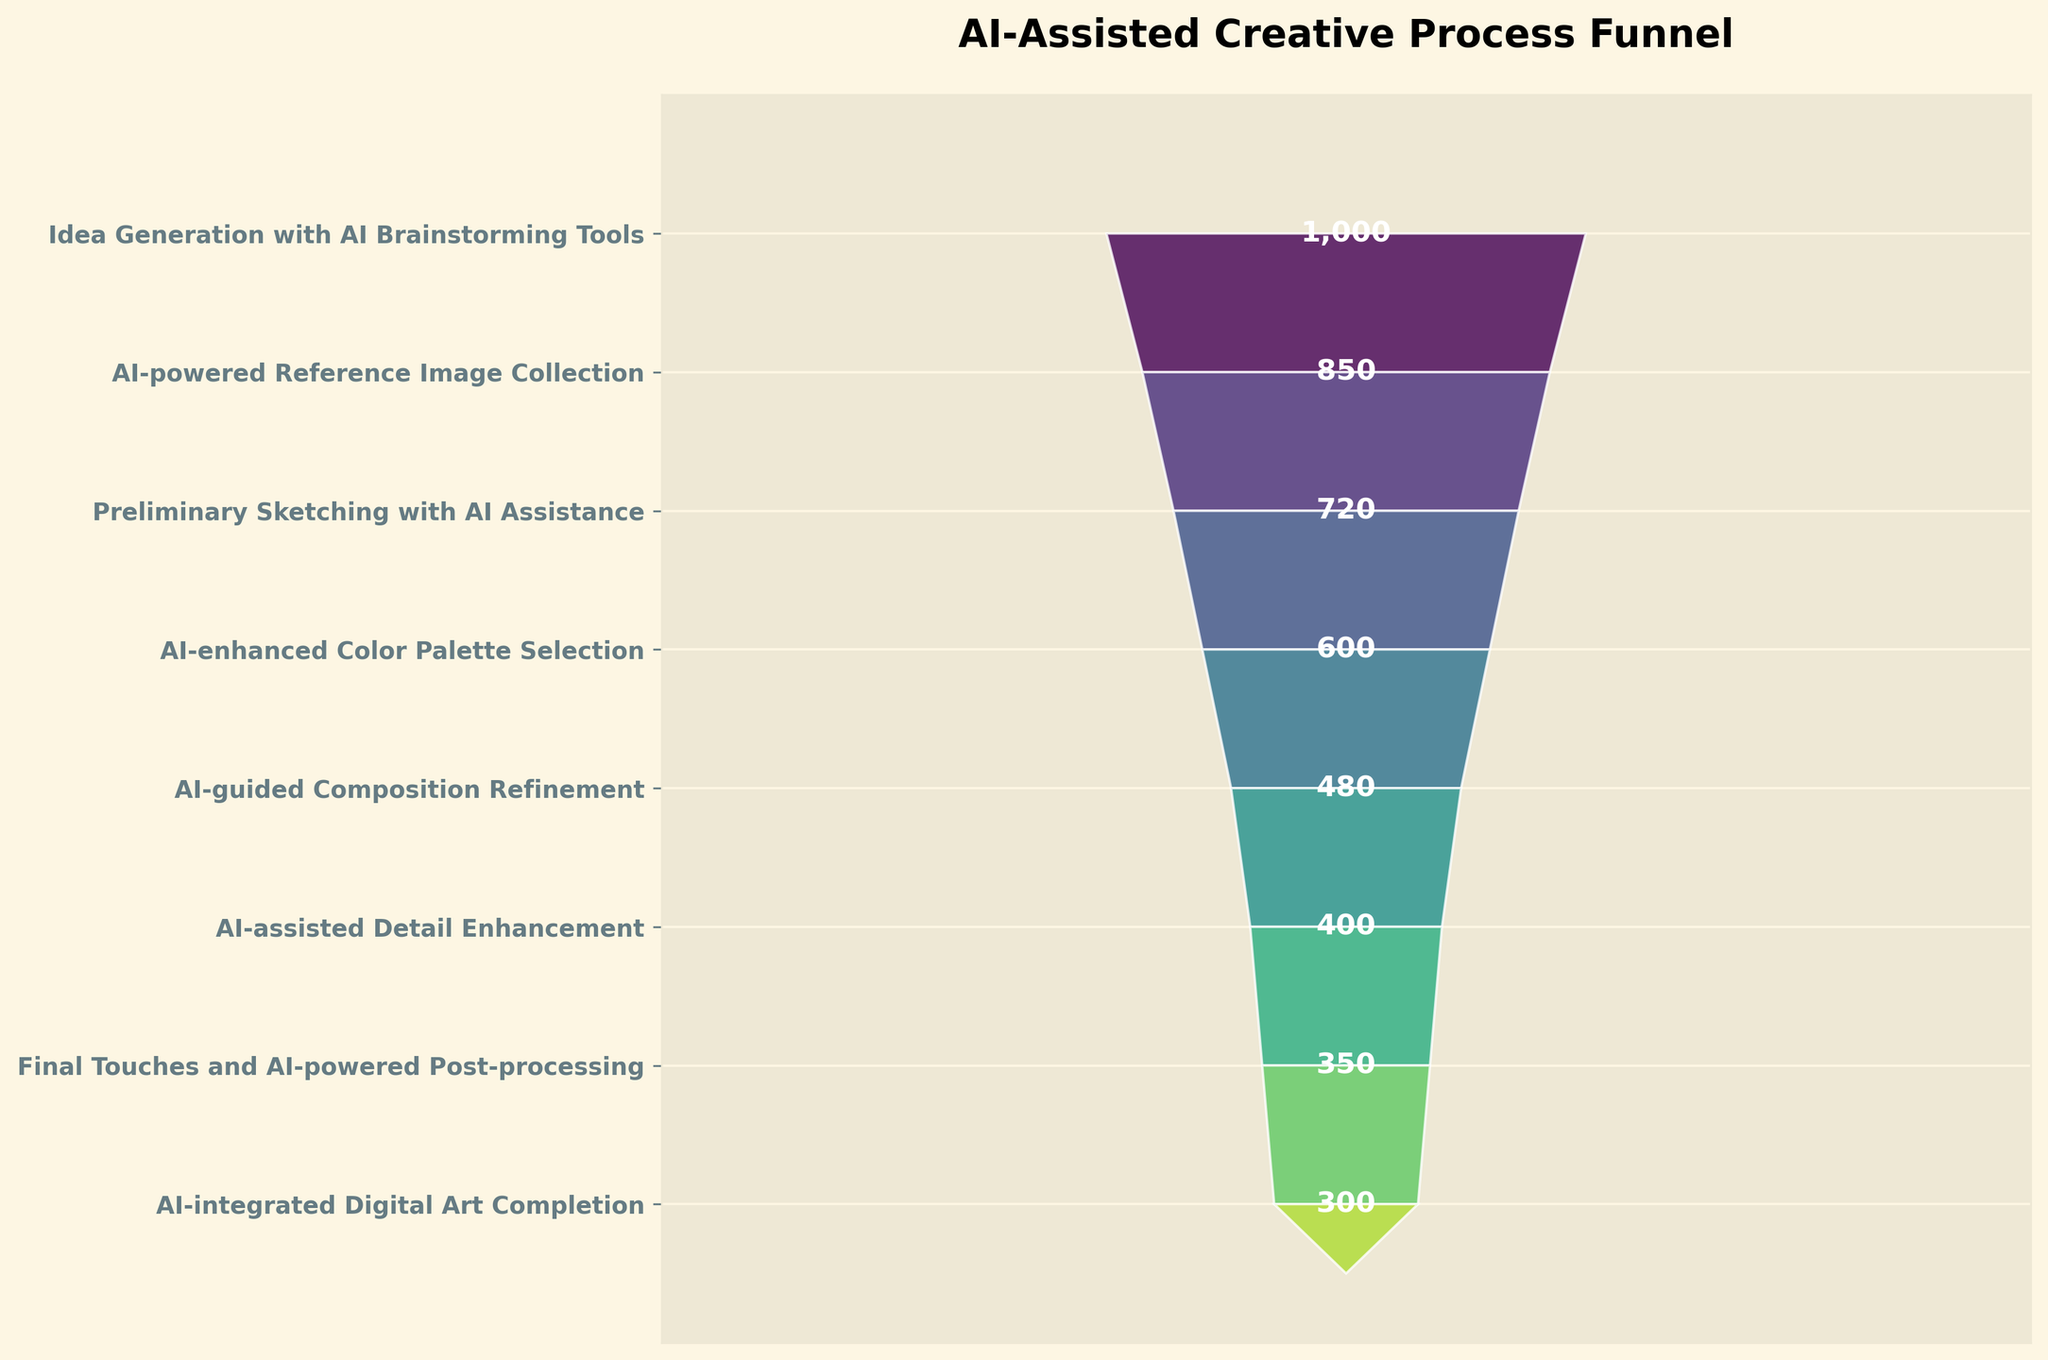What is the title of the funnel chart? The title of the chart is usually found at the top center and it helps understand the overall theme of the visualization. The title here clearly indicates the focus on the stages of the AI-assisted creative process for digital artists.
Answer: AI-Assisted Creative Process Funnel How many stages are there in the AI-assisted creative process according to the funnel chart? Count the number of distinct stages listed on the y-axis of the funnel chart, which represents different phases of the process.
Answer: 8 Which stage has the highest number of users? Look for the stage at the widest part of the funnel at the top. The widths of each funnel section represent the number of users, so the first stage with the widest section will have the most users.
Answer: Idea Generation with AI Brainstorming Tools Which stage has the lowest number of users? Identify the narrowest part of the funnel, which typically represents the last stage in the process. The stage at the bottom will be the one with the fewest users.
Answer: AI-integrated Digital Art Completion How many users are involved in AI-enhanced Color Palette Selection? Find the corresponding label for "AI-enhanced Color Palette Selection" on the y-axis and read the number of users displayed beside it.
Answer: 600 What is the difference in the number of users between the first and last stage? Subtract the number of users in the last stage from the number of users in the first stage. The first stage has 1000 users and the last stage has 300 users. So, 1000 - 300 = 700.
Answer: 700 Which stage shows a greater drop in users: from "AI-powered Reference Image Collection" to "Preliminary Sketching with AI Assistance" or from "AI-enhanced Color Palette Selection" to "AI-guided Composition Refinement"? Calculate the difference in the number of users for both pairs of stages. For the first pair: 850 - 720 = 130 users. For the second pair: 600 - 480 = 120 users. Therefore, the drop from "AI-powered Reference Image Collection" to "Preliminary Sketching with AI Assistance" is greater.
Answer: AI-powered Reference Image Collection to Preliminary Sketching with AI Assistance What is the average number of users across all stages? Sum the number of users for all stages and divide by the number of stages. Sum = 1000 + 850 + 720 + 600 + 480 + 400 + 350 + 300 = 4700. The number of stages is 8. So, 4700 / 8 = 587.5.
Answer: 587.5 What percentage of users continue from "Preliminary Sketching with AI Assistance" to "AI-enhanced Color Palette Selection"? Divide the number of users in "AI-enhanced Color Palette Selection" by the number of users in "Preliminary Sketching with AI Assistance" and multiply by 100 to get the percentage: (600 / 720) * 100 ≈ 83.3%.
Answer: ≈ 83.3% Which stages have a user count between 400 and 800? Look for stages whose number of users falls within the specified range of 400 to 800. These stages are "Preliminary Sketching with AI Assistance" with 720 users, "AI-enhanced Color Palette Selection" with 600 users, "AI-guided Composition Refinement" with 480 users, and "AI-assisted Detail Enhancement" with 400 users.
Answer: Preliminary Sketching with AI Assistance, AI-enhanced Color Palette Selection, AI-guided Composition Refinement, AI-assisted Detail Enhancement 